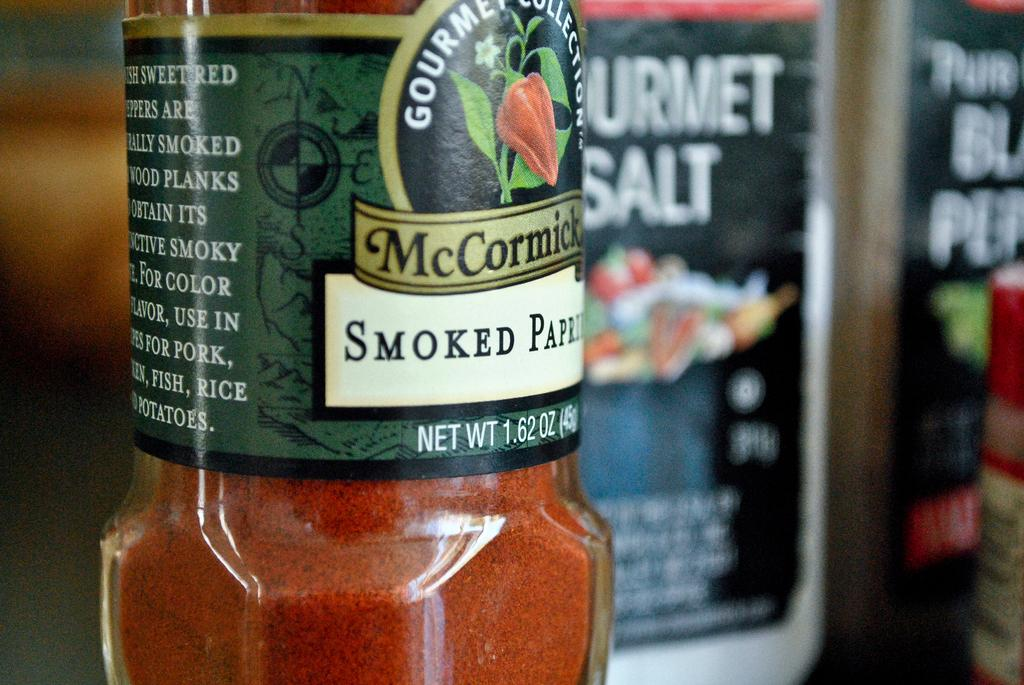<image>
Present a compact description of the photo's key features. A jar of smoked paprika sits in front of gourmet salt. 